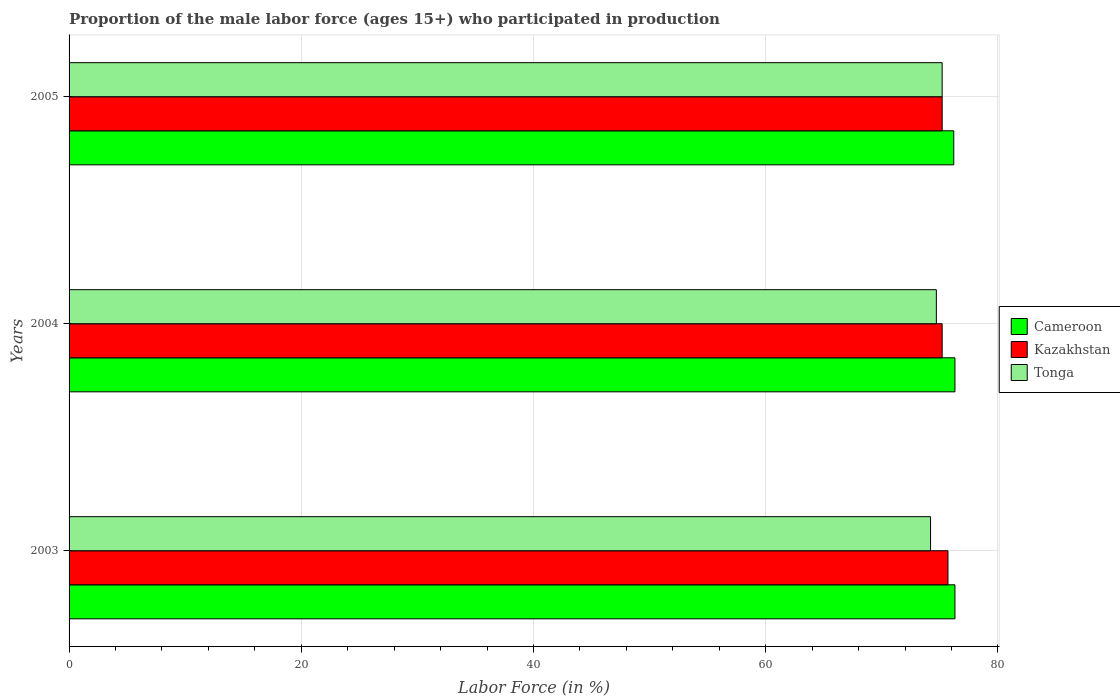How many groups of bars are there?
Make the answer very short. 3. Are the number of bars per tick equal to the number of legend labels?
Offer a very short reply. Yes. How many bars are there on the 3rd tick from the top?
Ensure brevity in your answer.  3. In how many cases, is the number of bars for a given year not equal to the number of legend labels?
Keep it short and to the point. 0. What is the proportion of the male labor force who participated in production in Kazakhstan in 2003?
Keep it short and to the point. 75.7. Across all years, what is the maximum proportion of the male labor force who participated in production in Tonga?
Offer a very short reply. 75.2. Across all years, what is the minimum proportion of the male labor force who participated in production in Kazakhstan?
Offer a terse response. 75.2. In which year was the proportion of the male labor force who participated in production in Tonga maximum?
Offer a very short reply. 2005. What is the total proportion of the male labor force who participated in production in Kazakhstan in the graph?
Make the answer very short. 226.1. What is the difference between the proportion of the male labor force who participated in production in Cameroon in 2004 and the proportion of the male labor force who participated in production in Tonga in 2003?
Provide a short and direct response. 2.1. What is the average proportion of the male labor force who participated in production in Cameroon per year?
Provide a short and direct response. 76.27. In the year 2004, what is the difference between the proportion of the male labor force who participated in production in Kazakhstan and proportion of the male labor force who participated in production in Cameroon?
Offer a terse response. -1.1. What is the ratio of the proportion of the male labor force who participated in production in Tonga in 2003 to that in 2005?
Give a very brief answer. 0.99. Is the difference between the proportion of the male labor force who participated in production in Kazakhstan in 2003 and 2005 greater than the difference between the proportion of the male labor force who participated in production in Cameroon in 2003 and 2005?
Provide a succinct answer. Yes. What is the difference between the highest and the second highest proportion of the male labor force who participated in production in Tonga?
Offer a terse response. 0.5. What is the difference between the highest and the lowest proportion of the male labor force who participated in production in Cameroon?
Your answer should be very brief. 0.1. In how many years, is the proportion of the male labor force who participated in production in Tonga greater than the average proportion of the male labor force who participated in production in Tonga taken over all years?
Offer a very short reply. 1. What does the 3rd bar from the top in 2005 represents?
Your answer should be compact. Cameroon. What does the 1st bar from the bottom in 2005 represents?
Your answer should be compact. Cameroon. How many bars are there?
Give a very brief answer. 9. Are all the bars in the graph horizontal?
Ensure brevity in your answer.  Yes. How many years are there in the graph?
Make the answer very short. 3. What is the difference between two consecutive major ticks on the X-axis?
Your answer should be compact. 20. Are the values on the major ticks of X-axis written in scientific E-notation?
Your answer should be very brief. No. Does the graph contain any zero values?
Provide a succinct answer. No. Does the graph contain grids?
Ensure brevity in your answer.  Yes. How many legend labels are there?
Provide a short and direct response. 3. What is the title of the graph?
Your answer should be compact. Proportion of the male labor force (ages 15+) who participated in production. What is the label or title of the Y-axis?
Your response must be concise. Years. What is the Labor Force (in %) in Cameroon in 2003?
Ensure brevity in your answer.  76.3. What is the Labor Force (in %) in Kazakhstan in 2003?
Offer a terse response. 75.7. What is the Labor Force (in %) in Tonga in 2003?
Make the answer very short. 74.2. What is the Labor Force (in %) in Cameroon in 2004?
Offer a terse response. 76.3. What is the Labor Force (in %) of Kazakhstan in 2004?
Your answer should be compact. 75.2. What is the Labor Force (in %) in Tonga in 2004?
Ensure brevity in your answer.  74.7. What is the Labor Force (in %) in Cameroon in 2005?
Give a very brief answer. 76.2. What is the Labor Force (in %) of Kazakhstan in 2005?
Give a very brief answer. 75.2. What is the Labor Force (in %) of Tonga in 2005?
Your answer should be very brief. 75.2. Across all years, what is the maximum Labor Force (in %) of Cameroon?
Your response must be concise. 76.3. Across all years, what is the maximum Labor Force (in %) in Kazakhstan?
Your answer should be very brief. 75.7. Across all years, what is the maximum Labor Force (in %) in Tonga?
Make the answer very short. 75.2. Across all years, what is the minimum Labor Force (in %) in Cameroon?
Your answer should be compact. 76.2. Across all years, what is the minimum Labor Force (in %) in Kazakhstan?
Provide a short and direct response. 75.2. Across all years, what is the minimum Labor Force (in %) of Tonga?
Your answer should be compact. 74.2. What is the total Labor Force (in %) in Cameroon in the graph?
Ensure brevity in your answer.  228.8. What is the total Labor Force (in %) in Kazakhstan in the graph?
Keep it short and to the point. 226.1. What is the total Labor Force (in %) in Tonga in the graph?
Your answer should be very brief. 224.1. What is the difference between the Labor Force (in %) in Cameroon in 2003 and that in 2004?
Keep it short and to the point. 0. What is the difference between the Labor Force (in %) in Tonga in 2003 and that in 2004?
Your response must be concise. -0.5. What is the difference between the Labor Force (in %) of Cameroon in 2003 and that in 2005?
Your answer should be compact. 0.1. What is the difference between the Labor Force (in %) of Tonga in 2003 and that in 2005?
Your answer should be compact. -1. What is the difference between the Labor Force (in %) in Tonga in 2004 and that in 2005?
Provide a succinct answer. -0.5. What is the difference between the Labor Force (in %) of Cameroon in 2003 and the Labor Force (in %) of Kazakhstan in 2005?
Give a very brief answer. 1.1. What is the difference between the Labor Force (in %) of Cameroon in 2003 and the Labor Force (in %) of Tonga in 2005?
Provide a short and direct response. 1.1. What is the difference between the Labor Force (in %) in Kazakhstan in 2003 and the Labor Force (in %) in Tonga in 2005?
Your answer should be very brief. 0.5. What is the difference between the Labor Force (in %) of Cameroon in 2004 and the Labor Force (in %) of Tonga in 2005?
Your answer should be very brief. 1.1. What is the average Labor Force (in %) of Cameroon per year?
Your answer should be compact. 76.27. What is the average Labor Force (in %) in Kazakhstan per year?
Make the answer very short. 75.37. What is the average Labor Force (in %) of Tonga per year?
Offer a very short reply. 74.7. In the year 2003, what is the difference between the Labor Force (in %) in Cameroon and Labor Force (in %) in Kazakhstan?
Your response must be concise. 0.6. In the year 2003, what is the difference between the Labor Force (in %) of Cameroon and Labor Force (in %) of Tonga?
Ensure brevity in your answer.  2.1. In the year 2004, what is the difference between the Labor Force (in %) in Cameroon and Labor Force (in %) in Tonga?
Your response must be concise. 1.6. In the year 2004, what is the difference between the Labor Force (in %) in Kazakhstan and Labor Force (in %) in Tonga?
Offer a very short reply. 0.5. In the year 2005, what is the difference between the Labor Force (in %) in Cameroon and Labor Force (in %) in Tonga?
Provide a succinct answer. 1. In the year 2005, what is the difference between the Labor Force (in %) in Kazakhstan and Labor Force (in %) in Tonga?
Your answer should be very brief. 0. What is the ratio of the Labor Force (in %) in Cameroon in 2003 to that in 2004?
Give a very brief answer. 1. What is the ratio of the Labor Force (in %) of Kazakhstan in 2003 to that in 2004?
Provide a short and direct response. 1.01. What is the ratio of the Labor Force (in %) in Tonga in 2003 to that in 2004?
Make the answer very short. 0.99. What is the ratio of the Labor Force (in %) in Kazakhstan in 2003 to that in 2005?
Offer a very short reply. 1.01. What is the ratio of the Labor Force (in %) of Tonga in 2003 to that in 2005?
Your answer should be compact. 0.99. What is the ratio of the Labor Force (in %) of Kazakhstan in 2004 to that in 2005?
Offer a terse response. 1. What is the ratio of the Labor Force (in %) of Tonga in 2004 to that in 2005?
Provide a short and direct response. 0.99. What is the difference between the highest and the second highest Labor Force (in %) in Cameroon?
Your answer should be compact. 0. What is the difference between the highest and the second highest Labor Force (in %) of Kazakhstan?
Provide a succinct answer. 0.5. What is the difference between the highest and the second highest Labor Force (in %) of Tonga?
Your response must be concise. 0.5. 